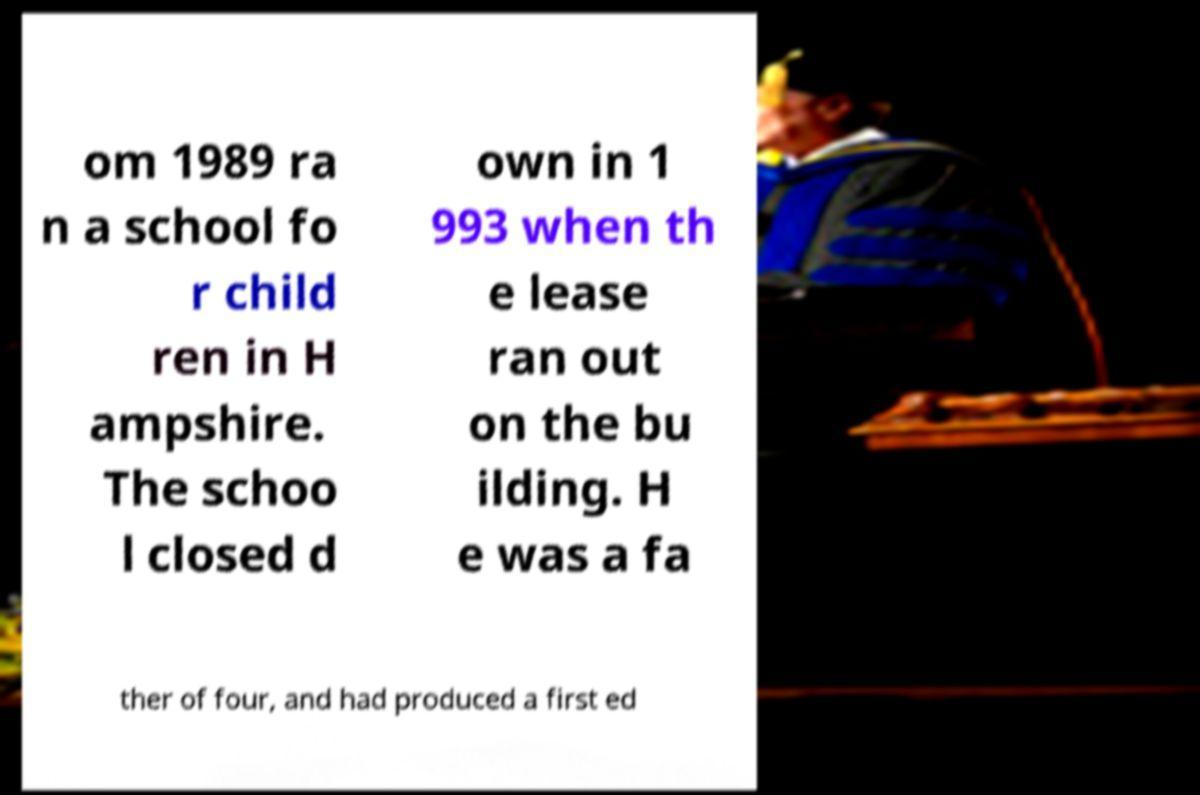Please read and relay the text visible in this image. What does it say? om 1989 ra n a school fo r child ren in H ampshire. The schoo l closed d own in 1 993 when th e lease ran out on the bu ilding. H e was a fa ther of four, and had produced a first ed 